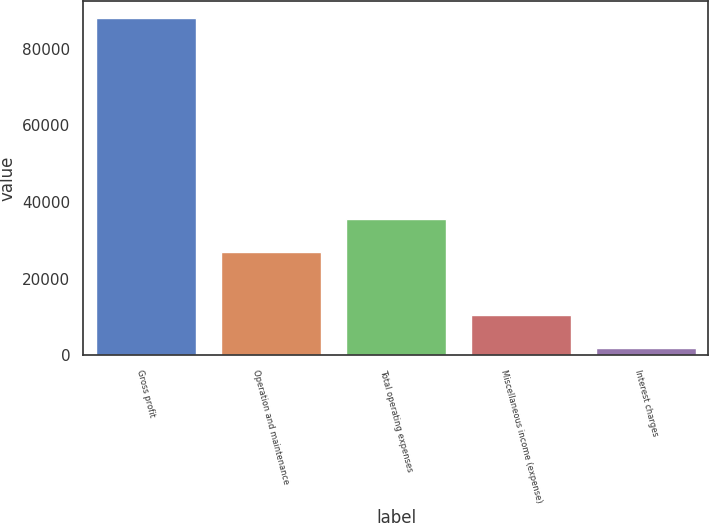<chart> <loc_0><loc_0><loc_500><loc_500><bar_chart><fcel>Gross profit<fcel>Operation and maintenance<fcel>Total operating expenses<fcel>Miscellaneous income (expense)<fcel>Interest charges<nl><fcel>87955<fcel>26963<fcel>35559.9<fcel>10582.9<fcel>1986<nl></chart> 